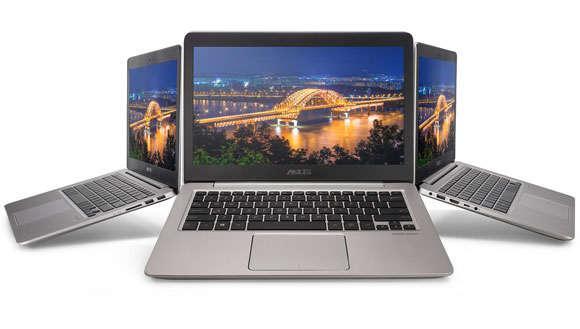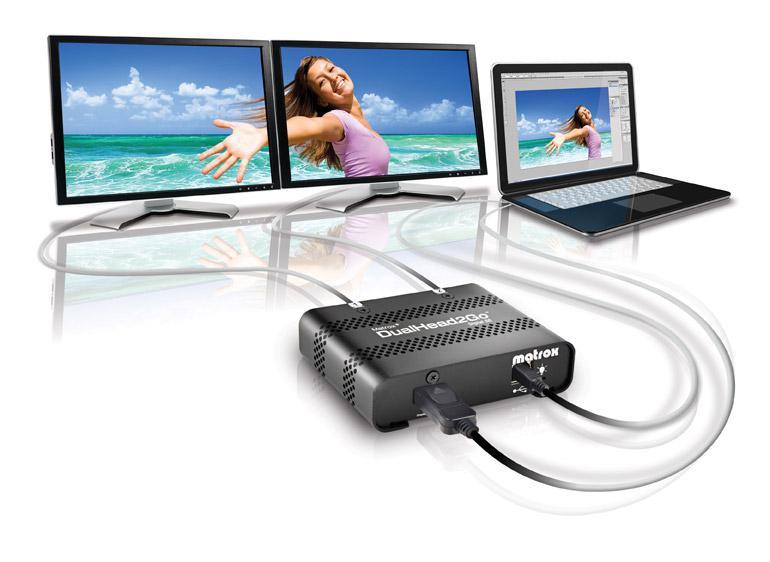The first image is the image on the left, the second image is the image on the right. Evaluate the accuracy of this statement regarding the images: "An image includes side-by-side monitors with blue curving lines on the screen, and a smaller laptop.". Is it true? Answer yes or no. No. The first image is the image on the left, the second image is the image on the right. Evaluate the accuracy of this statement regarding the images: "There is exactly one laptop in the left image.". Is it true? Answer yes or no. No. 